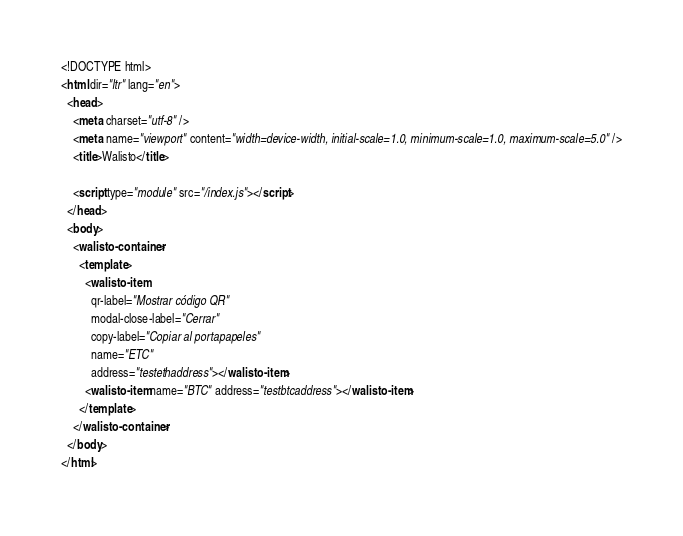<code> <loc_0><loc_0><loc_500><loc_500><_HTML_><!DOCTYPE html>
<html dir="ltr" lang="en">
  <head>
    <meta charset="utf-8" />
    <meta name="viewport" content="width=device-width, initial-scale=1.0, minimum-scale=1.0, maximum-scale=5.0" />
    <title>Walisto</title>

    <script type="module" src="/index.js"></script>
  </head>
  <body>
    <walisto-container>
      <template>
        <walisto-item
          qr-label="Mostrar código QR"
          modal-close-label="Cerrar"
          copy-label="Copiar al portapapeles"
          name="ETC"
          address="testethaddress"></walisto-item>
        <walisto-item name="BTC" address="testbtcaddress"></walisto-item>
      </template>
    </walisto-container>
  </body>
</html>
</code> 